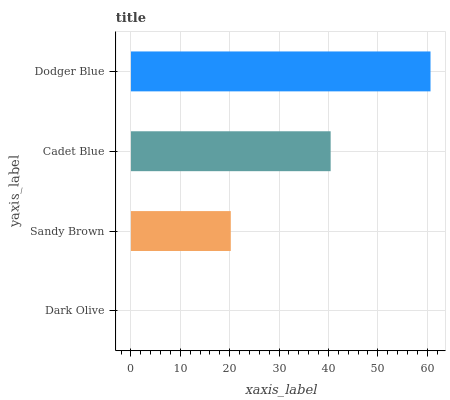Is Dark Olive the minimum?
Answer yes or no. Yes. Is Dodger Blue the maximum?
Answer yes or no. Yes. Is Sandy Brown the minimum?
Answer yes or no. No. Is Sandy Brown the maximum?
Answer yes or no. No. Is Sandy Brown greater than Dark Olive?
Answer yes or no. Yes. Is Dark Olive less than Sandy Brown?
Answer yes or no. Yes. Is Dark Olive greater than Sandy Brown?
Answer yes or no. No. Is Sandy Brown less than Dark Olive?
Answer yes or no. No. Is Cadet Blue the high median?
Answer yes or no. Yes. Is Sandy Brown the low median?
Answer yes or no. Yes. Is Dodger Blue the high median?
Answer yes or no. No. Is Dark Olive the low median?
Answer yes or no. No. 